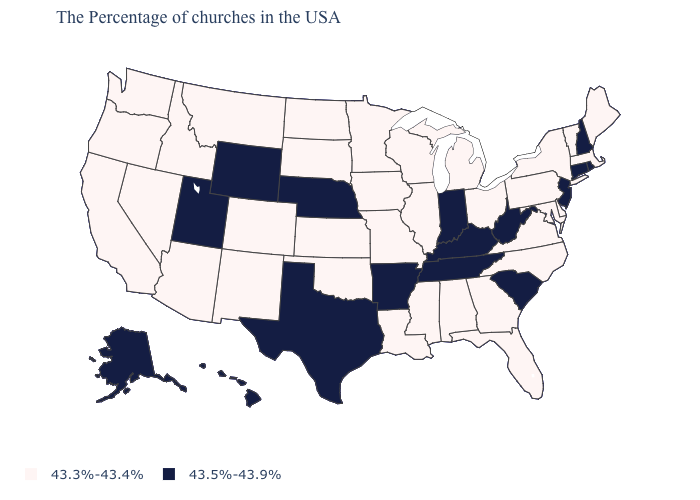Name the states that have a value in the range 43.5%-43.9%?
Quick response, please. Rhode Island, New Hampshire, Connecticut, New Jersey, South Carolina, West Virginia, Kentucky, Indiana, Tennessee, Arkansas, Nebraska, Texas, Wyoming, Utah, Alaska, Hawaii. Which states hav the highest value in the South?
Short answer required. South Carolina, West Virginia, Kentucky, Tennessee, Arkansas, Texas. What is the value of New York?
Quick response, please. 43.3%-43.4%. What is the value of Alaska?
Quick response, please. 43.5%-43.9%. Which states have the lowest value in the USA?
Answer briefly. Maine, Massachusetts, Vermont, New York, Delaware, Maryland, Pennsylvania, Virginia, North Carolina, Ohio, Florida, Georgia, Michigan, Alabama, Wisconsin, Illinois, Mississippi, Louisiana, Missouri, Minnesota, Iowa, Kansas, Oklahoma, South Dakota, North Dakota, Colorado, New Mexico, Montana, Arizona, Idaho, Nevada, California, Washington, Oregon. Does Illinois have a lower value than Alaska?
Concise answer only. Yes. Is the legend a continuous bar?
Write a very short answer. No. What is the value of Wisconsin?
Be succinct. 43.3%-43.4%. What is the highest value in the USA?
Give a very brief answer. 43.5%-43.9%. Which states have the lowest value in the Northeast?
Write a very short answer. Maine, Massachusetts, Vermont, New York, Pennsylvania. Does Nebraska have the same value as New Hampshire?
Keep it brief. Yes. Among the states that border Virginia , does North Carolina have the highest value?
Quick response, please. No. What is the value of Missouri?
Write a very short answer. 43.3%-43.4%. Is the legend a continuous bar?
Give a very brief answer. No. Which states have the lowest value in the West?
Be succinct. Colorado, New Mexico, Montana, Arizona, Idaho, Nevada, California, Washington, Oregon. 